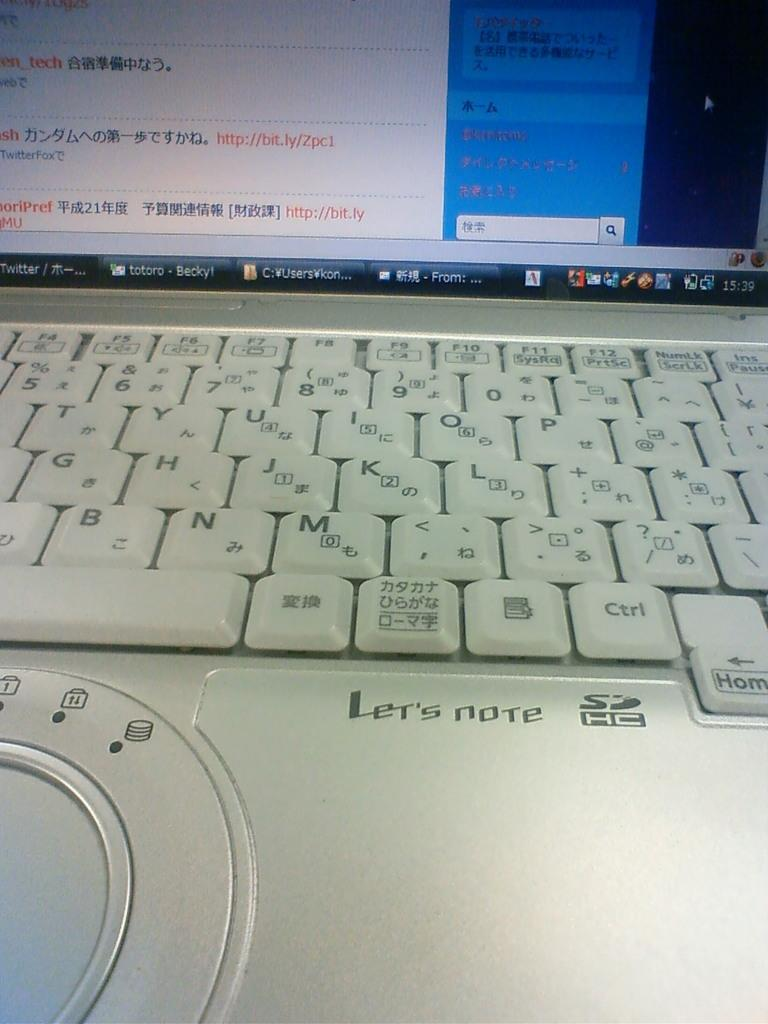<image>
Offer a succinct explanation of the picture presented. Keyboard that says "Let's Note" on it and a screen showing Japanese. 